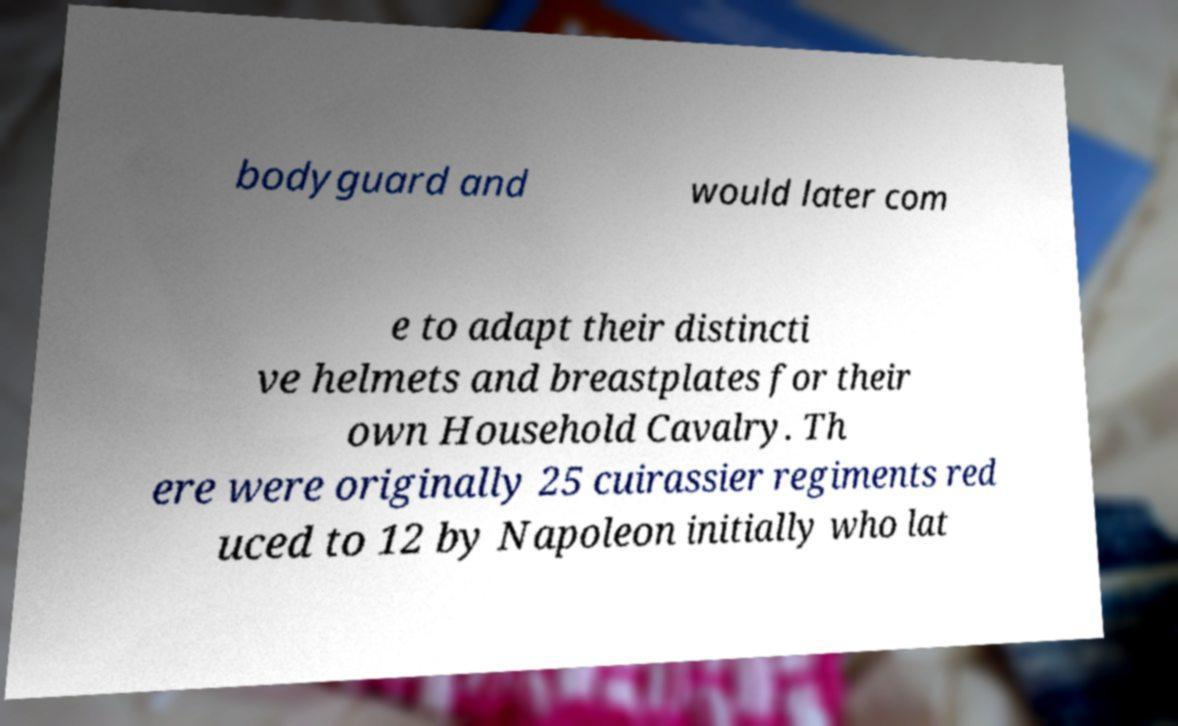I need the written content from this picture converted into text. Can you do that? bodyguard and would later com e to adapt their distincti ve helmets and breastplates for their own Household Cavalry. Th ere were originally 25 cuirassier regiments red uced to 12 by Napoleon initially who lat 